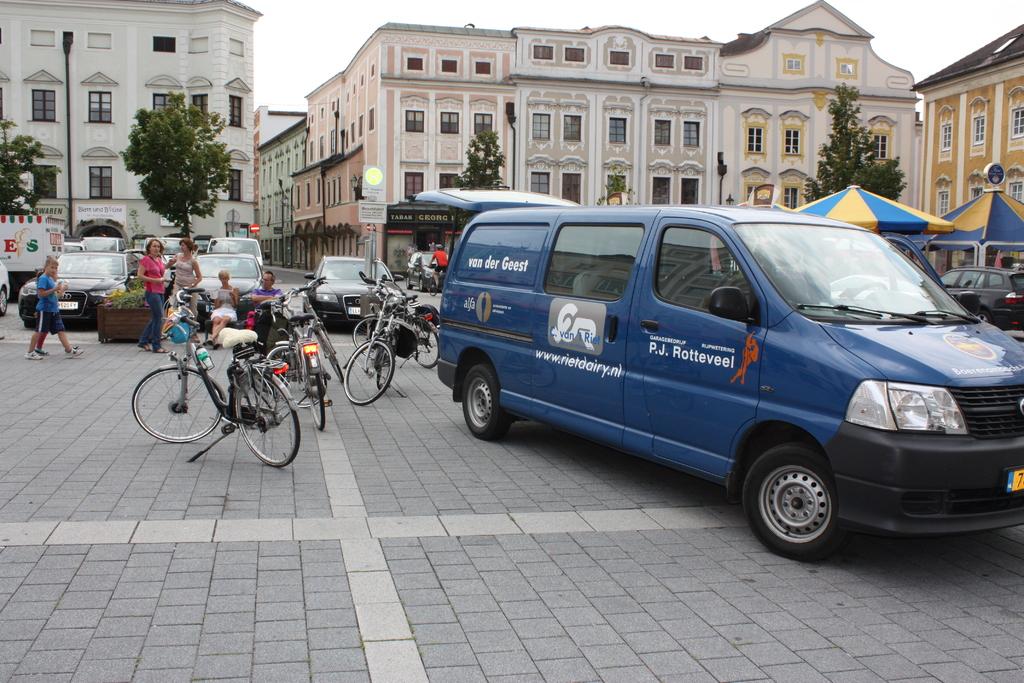What name is on the side of the blue van?
Offer a very short reply. P.j. rotteveel. 